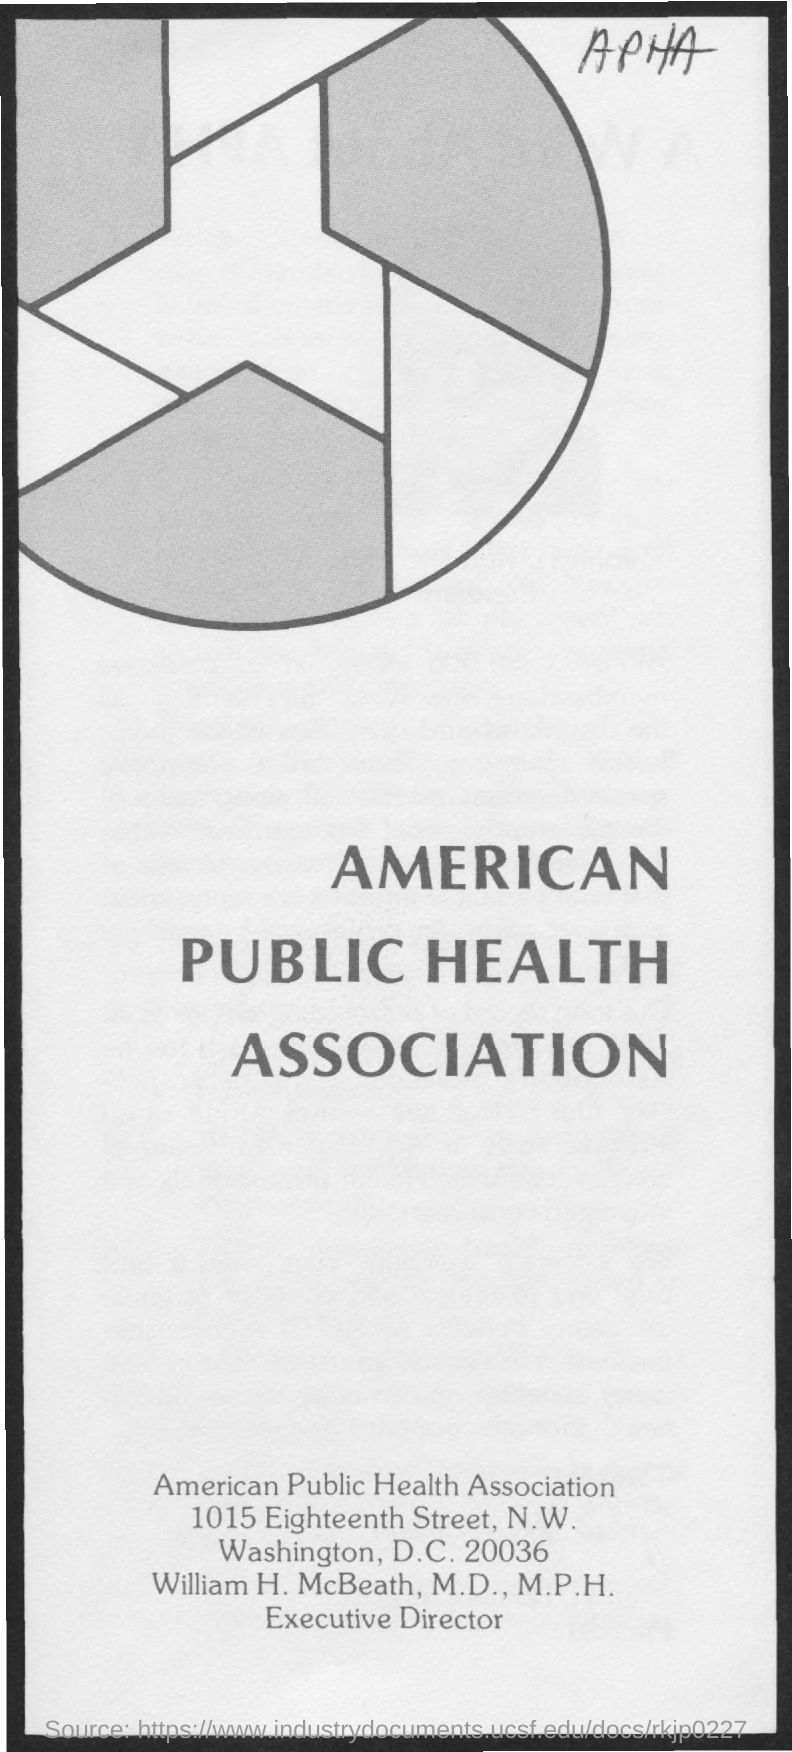Who is the Executive Director of American Public Health Association?
Ensure brevity in your answer.  William H. McBeath. 